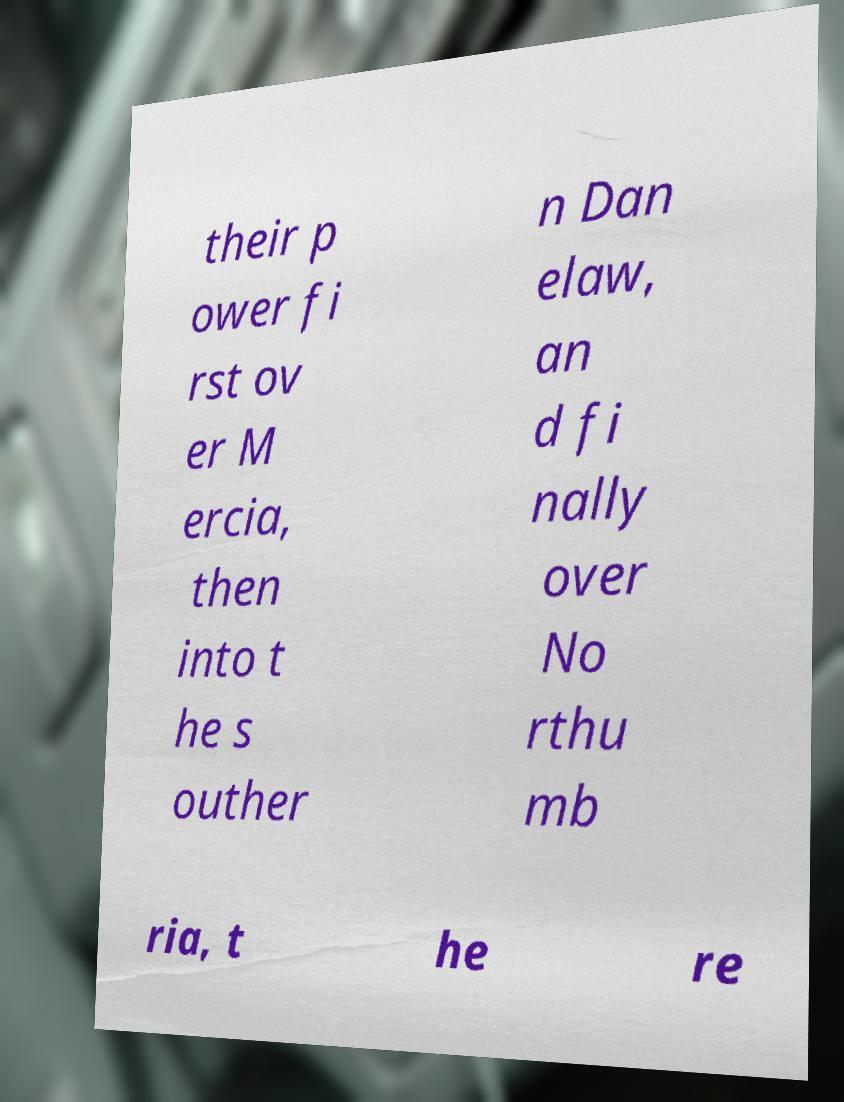For documentation purposes, I need the text within this image transcribed. Could you provide that? their p ower fi rst ov er M ercia, then into t he s outher n Dan elaw, an d fi nally over No rthu mb ria, t he re 